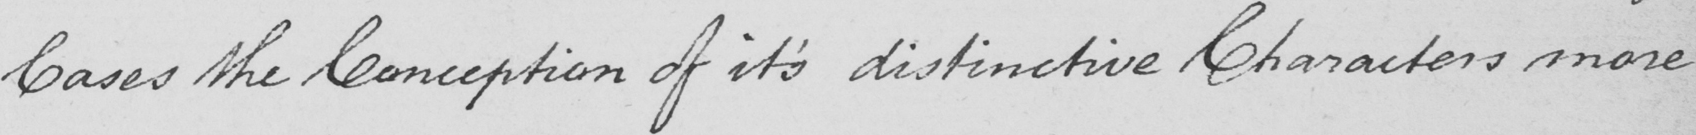Can you tell me what this handwritten text says? Cases the Conception of it ' s distinctive Characters more 